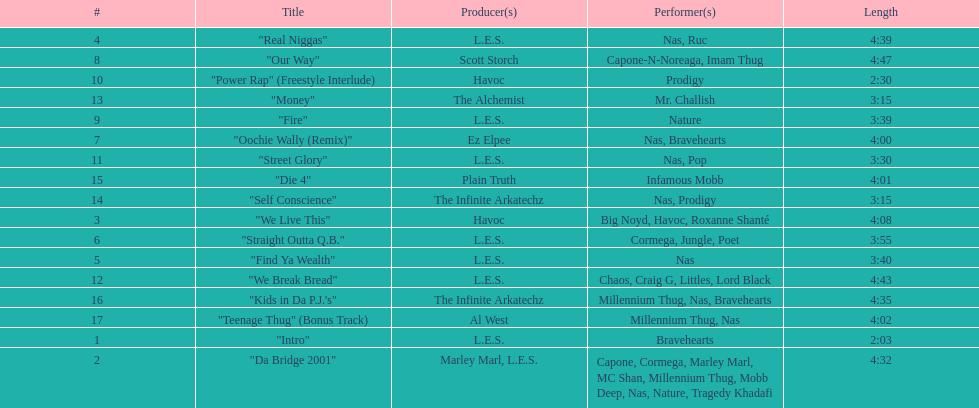Which is longer, fire or die 4? "Die 4". 